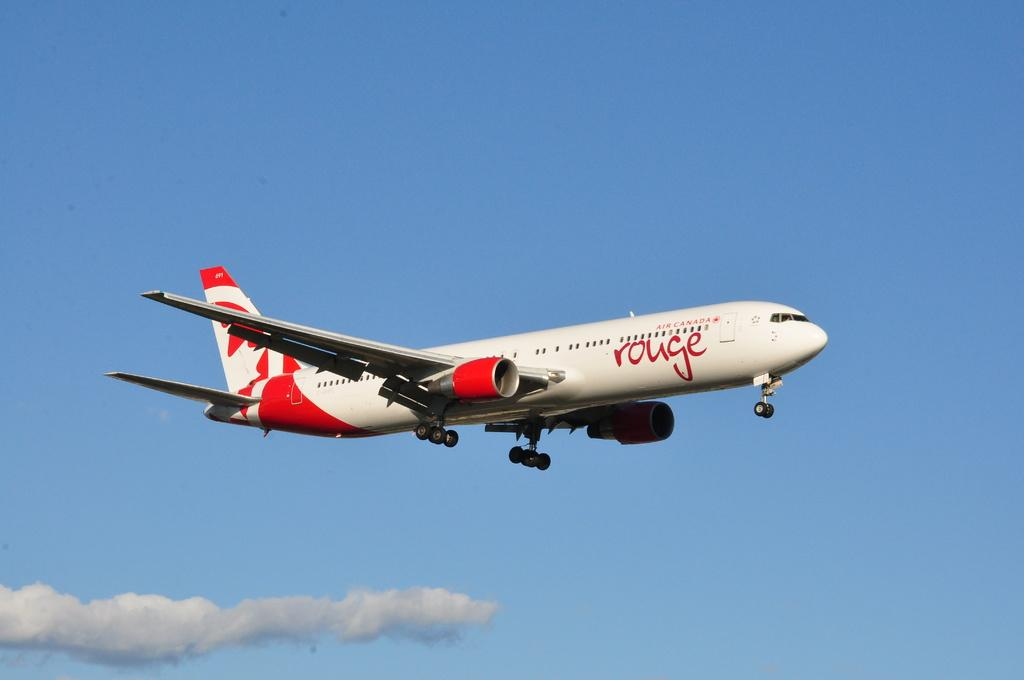What is the main subject of the image? The main subject of the image is an aircraft. What colors are used to paint the aircraft? The aircraft is in white and red color. What can be seen in the background of the image? The sky is visible in the background of the image. What colors are present in the sky? The sky is in blue and white color. Is there a calendar hanging on the aircraft in the image? There is no calendar present in the image. Can you see any silk fabric on the aircraft in the image? There is no silk fabric visible on the aircraft in the image. 